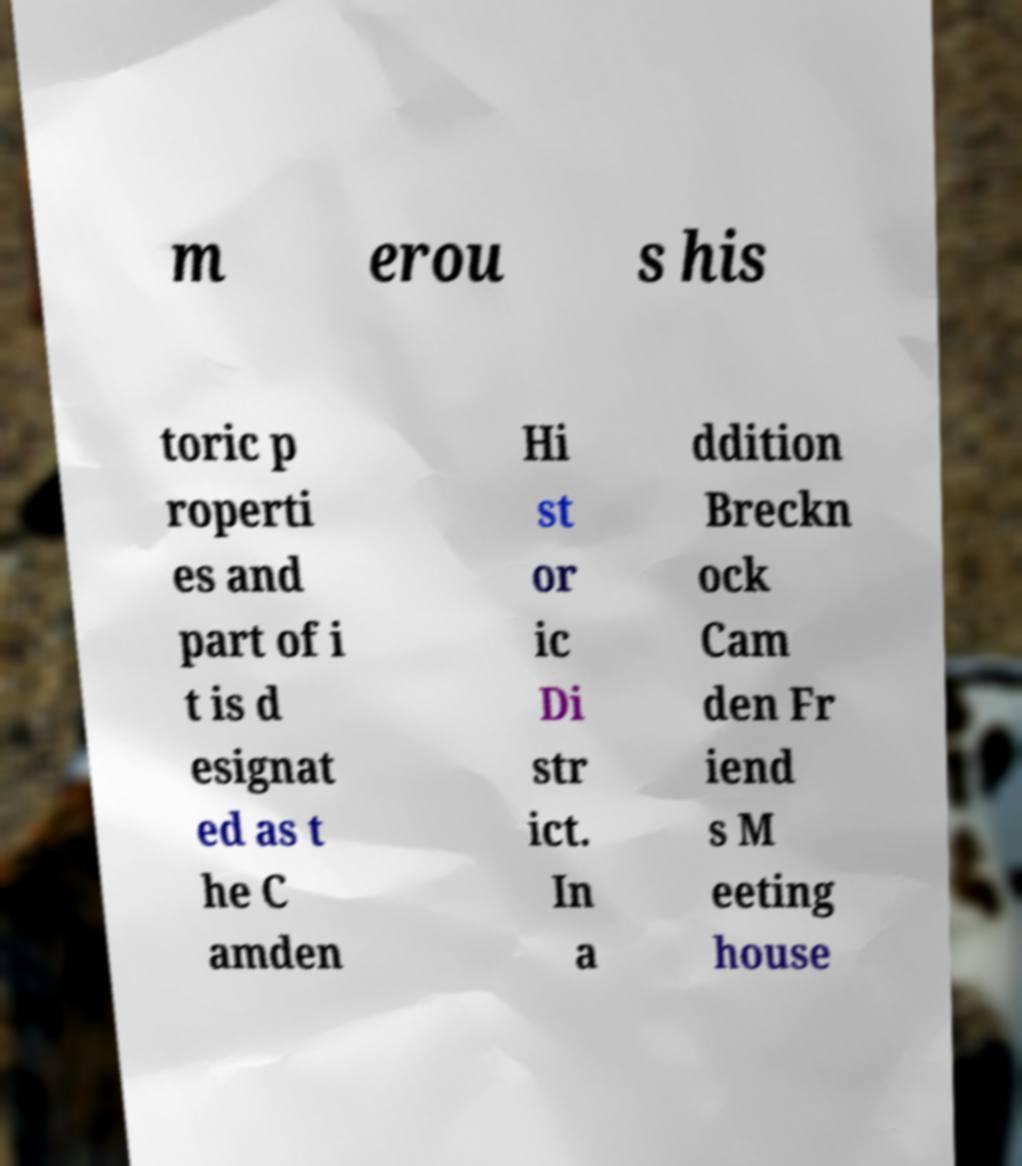Could you extract and type out the text from this image? m erou s his toric p roperti es and part of i t is d esignat ed as t he C amden Hi st or ic Di str ict. In a ddition Breckn ock Cam den Fr iend s M eeting house 